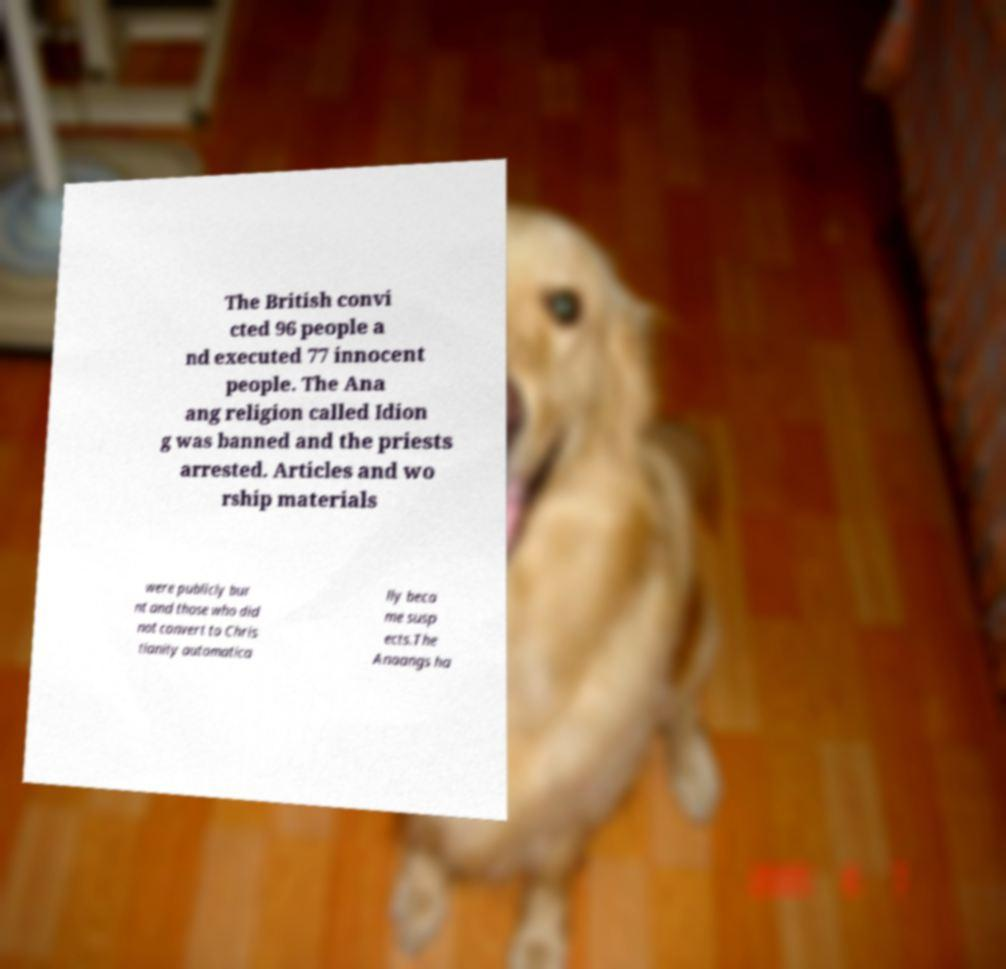What messages or text are displayed in this image? I need them in a readable, typed format. The British convi cted 96 people a nd executed 77 innocent people. The Ana ang religion called Idion g was banned and the priests arrested. Articles and wo rship materials were publicly bur nt and those who did not convert to Chris tianity automatica lly beca me susp ects.The Anaangs ha 